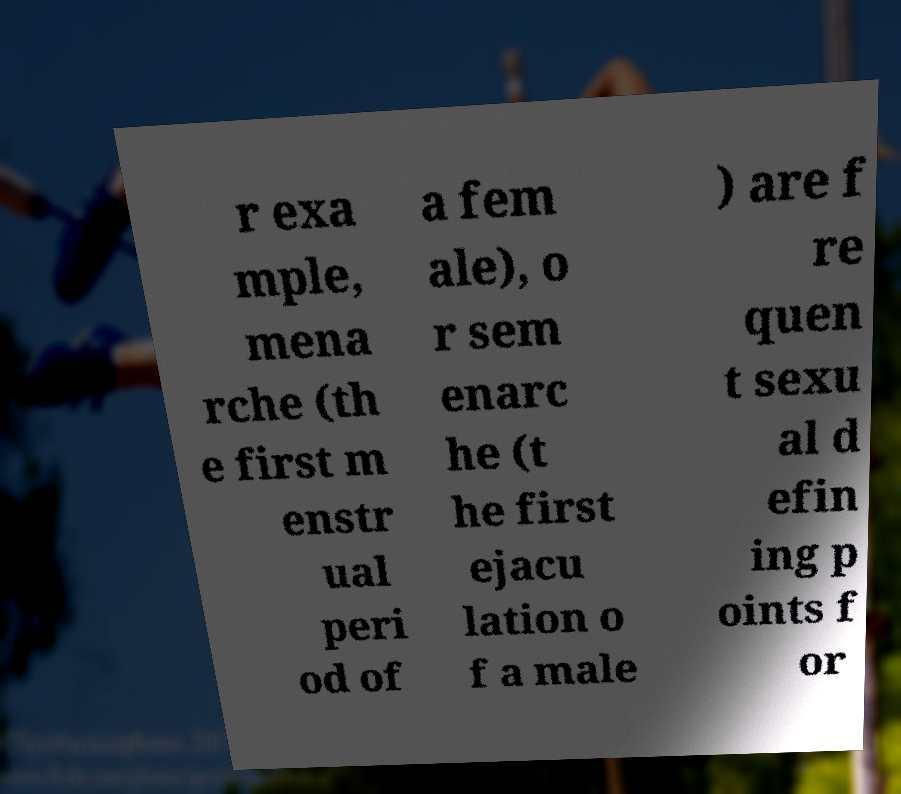There's text embedded in this image that I need extracted. Can you transcribe it verbatim? r exa mple, mena rche (th e first m enstr ual peri od of a fem ale), o r sem enarc he (t he first ejacu lation o f a male ) are f re quen t sexu al d efin ing p oints f or 